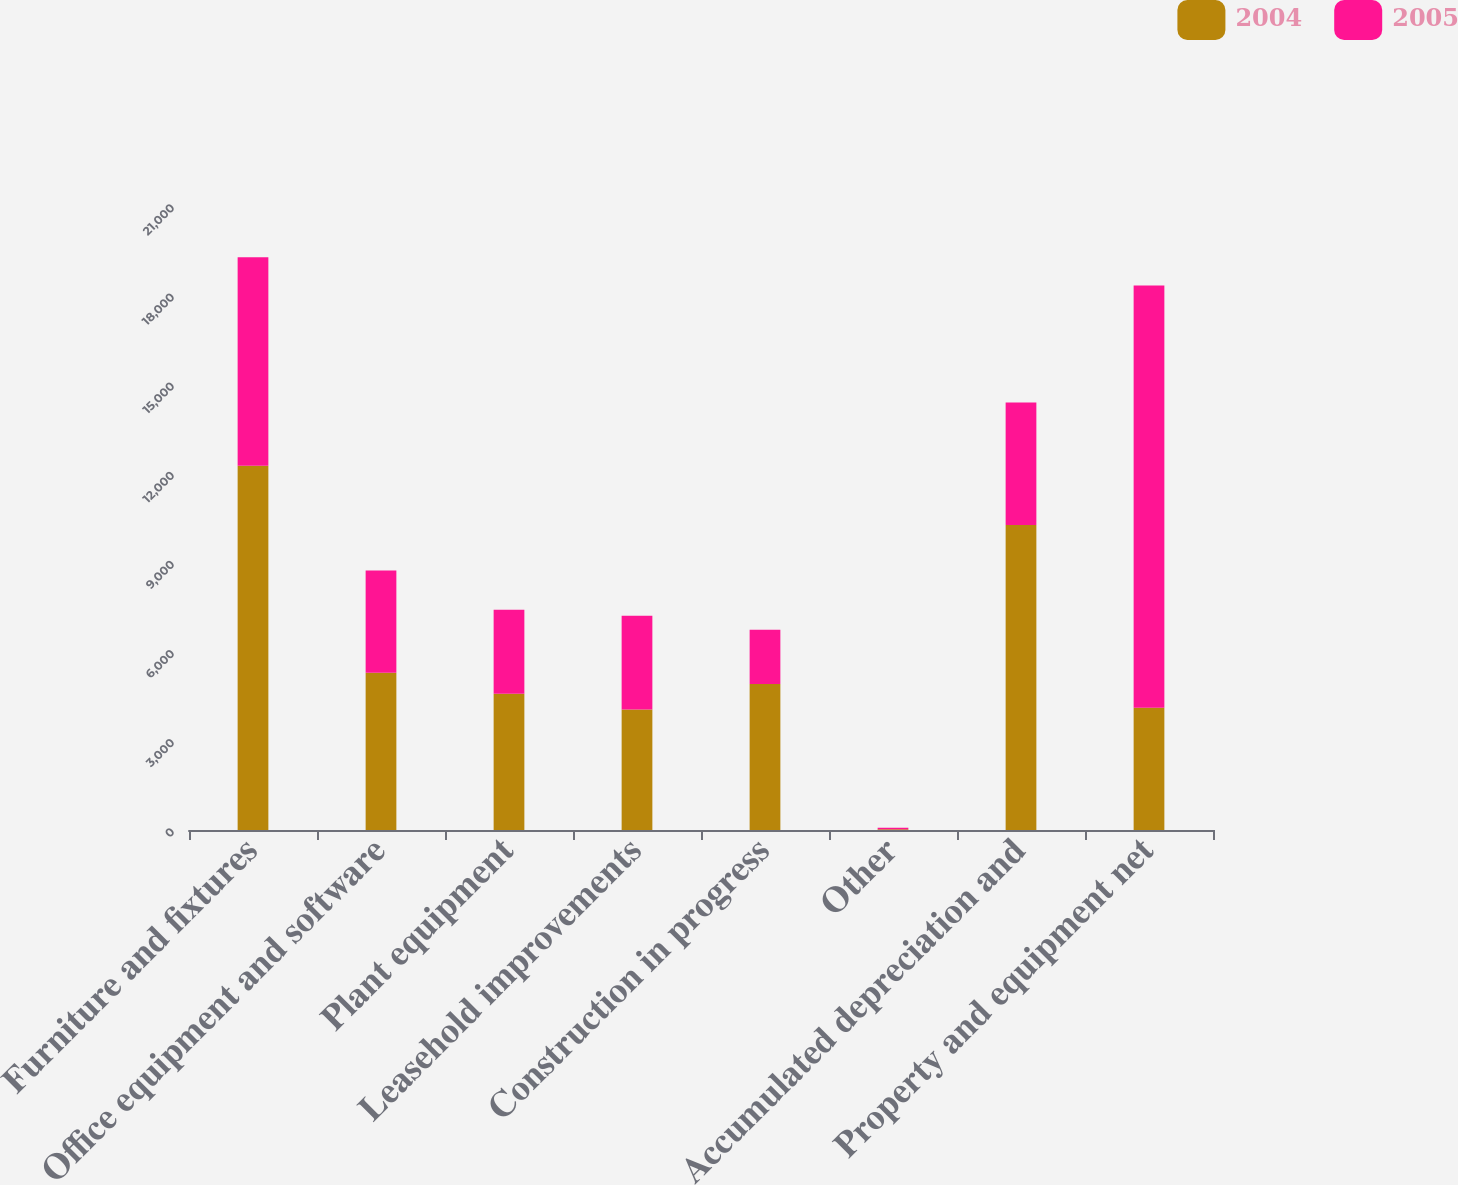<chart> <loc_0><loc_0><loc_500><loc_500><stacked_bar_chart><ecel><fcel>Furniture and fixtures<fcel>Office equipment and software<fcel>Plant equipment<fcel>Leasehold improvements<fcel>Construction in progress<fcel>Other<fcel>Accumulated depreciation and<fcel>Property and equipment net<nl><fcel>2004<fcel>12262<fcel>5290<fcel>4582<fcel>4058<fcel>4917<fcel>24<fcel>10268<fcel>4115<nl><fcel>2005<fcel>7017<fcel>3447<fcel>2834<fcel>3151<fcel>1825<fcel>52<fcel>4115<fcel>14211<nl></chart> 